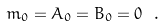<formula> <loc_0><loc_0><loc_500><loc_500>m _ { 0 } = A _ { 0 } = B _ { 0 } = 0 \ .</formula> 